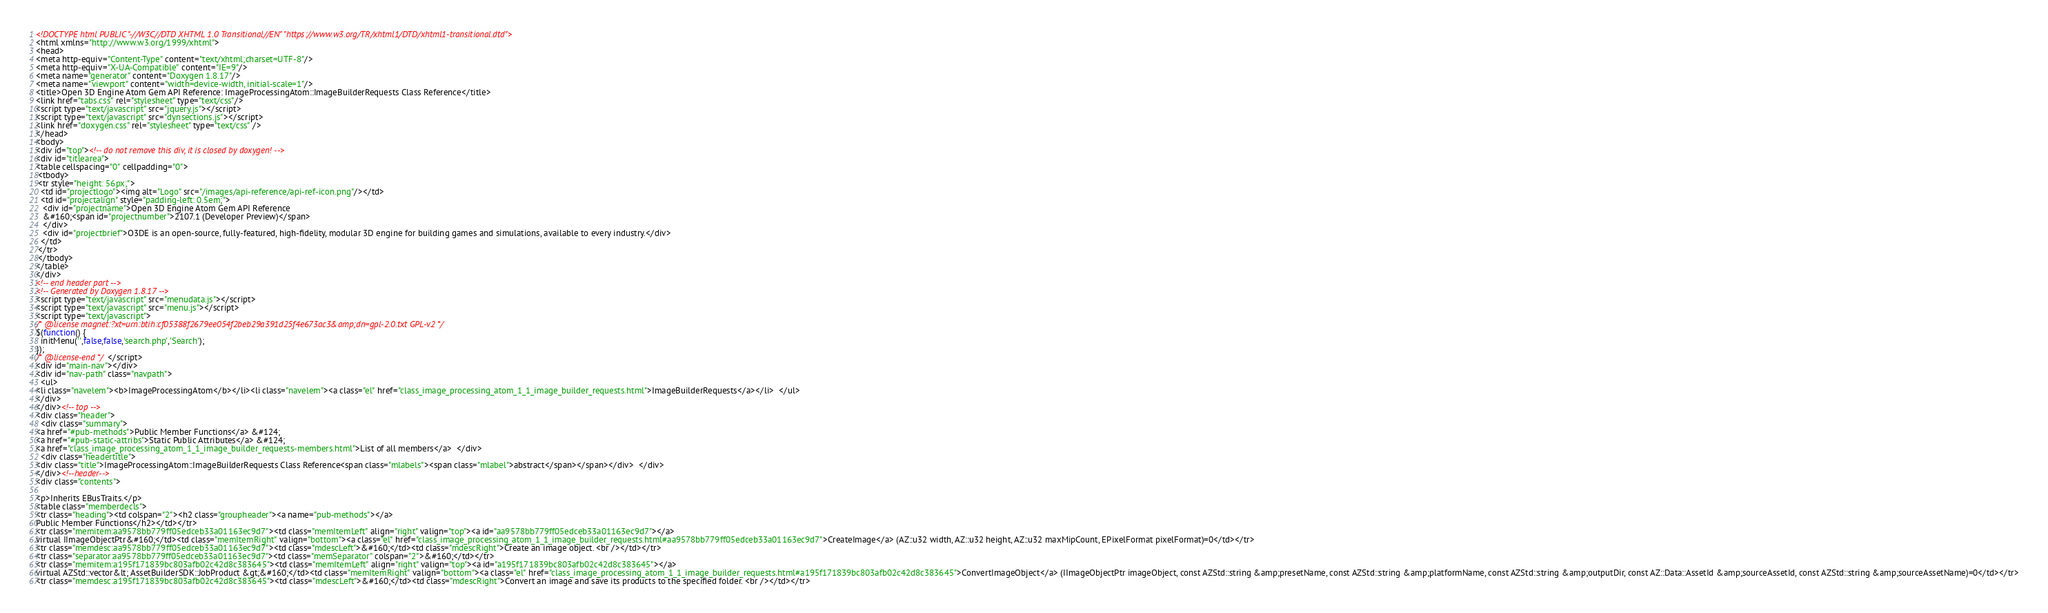<code> <loc_0><loc_0><loc_500><loc_500><_HTML_><!DOCTYPE html PUBLIC "-//W3C//DTD XHTML 1.0 Transitional//EN" "https://www.w3.org/TR/xhtml1/DTD/xhtml1-transitional.dtd">
<html xmlns="http://www.w3.org/1999/xhtml">
<head>
<meta http-equiv="Content-Type" content="text/xhtml;charset=UTF-8"/>
<meta http-equiv="X-UA-Compatible" content="IE=9"/>
<meta name="generator" content="Doxygen 1.8.17"/>
<meta name="viewport" content="width=device-width, initial-scale=1"/>
<title>Open 3D Engine Atom Gem API Reference: ImageProcessingAtom::ImageBuilderRequests Class Reference</title>
<link href="tabs.css" rel="stylesheet" type="text/css"/>
<script type="text/javascript" src="jquery.js"></script>
<script type="text/javascript" src="dynsections.js"></script>
<link href="doxygen.css" rel="stylesheet" type="text/css" />
</head>
<body>
<div id="top"><!-- do not remove this div, it is closed by doxygen! -->
<div id="titlearea">
<table cellspacing="0" cellpadding="0">
 <tbody>
 <tr style="height: 56px;">
  <td id="projectlogo"><img alt="Logo" src="/images/api-reference/api-ref-icon.png"/></td>
  <td id="projectalign" style="padding-left: 0.5em;">
   <div id="projectname">Open 3D Engine Atom Gem API Reference
   &#160;<span id="projectnumber">2107.1 (Developer Preview)</span>
   </div>
   <div id="projectbrief">O3DE is an open-source, fully-featured, high-fidelity, modular 3D engine for building games and simulations, available to every industry.</div>
  </td>
 </tr>
 </tbody>
</table>
</div>
<!-- end header part -->
<!-- Generated by Doxygen 1.8.17 -->
<script type="text/javascript" src="menudata.js"></script>
<script type="text/javascript" src="menu.js"></script>
<script type="text/javascript">
/* @license magnet:?xt=urn:btih:cf05388f2679ee054f2beb29a391d25f4e673ac3&amp;dn=gpl-2.0.txt GPL-v2 */
$(function() {
  initMenu('',false,false,'search.php','Search');
});
/* @license-end */</script>
<div id="main-nav"></div>
<div id="nav-path" class="navpath">
  <ul>
<li class="navelem"><b>ImageProcessingAtom</b></li><li class="navelem"><a class="el" href="class_image_processing_atom_1_1_image_builder_requests.html">ImageBuilderRequests</a></li>  </ul>
</div>
</div><!-- top -->
<div class="header">
  <div class="summary">
<a href="#pub-methods">Public Member Functions</a> &#124;
<a href="#pub-static-attribs">Static Public Attributes</a> &#124;
<a href="class_image_processing_atom_1_1_image_builder_requests-members.html">List of all members</a>  </div>
  <div class="headertitle">
<div class="title">ImageProcessingAtom::ImageBuilderRequests Class Reference<span class="mlabels"><span class="mlabel">abstract</span></span></div>  </div>
</div><!--header-->
<div class="contents">

<p>Inherits EBusTraits.</p>
<table class="memberdecls">
<tr class="heading"><td colspan="2"><h2 class="groupheader"><a name="pub-methods"></a>
Public Member Functions</h2></td></tr>
<tr class="memitem:aa9578bb779ff05edceb33a01163ec9d7"><td class="memItemLeft" align="right" valign="top"><a id="aa9578bb779ff05edceb33a01163ec9d7"></a>
virtual IImageObjectPtr&#160;</td><td class="memItemRight" valign="bottom"><a class="el" href="class_image_processing_atom_1_1_image_builder_requests.html#aa9578bb779ff05edceb33a01163ec9d7">CreateImage</a> (AZ::u32 width, AZ::u32 height, AZ::u32 maxMipCount, EPixelFormat pixelFormat)=0</td></tr>
<tr class="memdesc:aa9578bb779ff05edceb33a01163ec9d7"><td class="mdescLeft">&#160;</td><td class="mdescRight">Create an image object. <br /></td></tr>
<tr class="separator:aa9578bb779ff05edceb33a01163ec9d7"><td class="memSeparator" colspan="2">&#160;</td></tr>
<tr class="memitem:a195f171839bc803afb02c42d8c383645"><td class="memItemLeft" align="right" valign="top"><a id="a195f171839bc803afb02c42d8c383645"></a>
virtual AZStd::vector&lt; AssetBuilderSDK::JobProduct &gt;&#160;</td><td class="memItemRight" valign="bottom"><a class="el" href="class_image_processing_atom_1_1_image_builder_requests.html#a195f171839bc803afb02c42d8c383645">ConvertImageObject</a> (IImageObjectPtr imageObject, const AZStd::string &amp;presetName, const AZStd::string &amp;platformName, const AZStd::string &amp;outputDir, const AZ::Data::AssetId &amp;sourceAssetId, const AZStd::string &amp;sourceAssetName)=0</td></tr>
<tr class="memdesc:a195f171839bc803afb02c42d8c383645"><td class="mdescLeft">&#160;</td><td class="mdescRight">Convert an image and save its products to the specified folder. <br /></td></tr></code> 